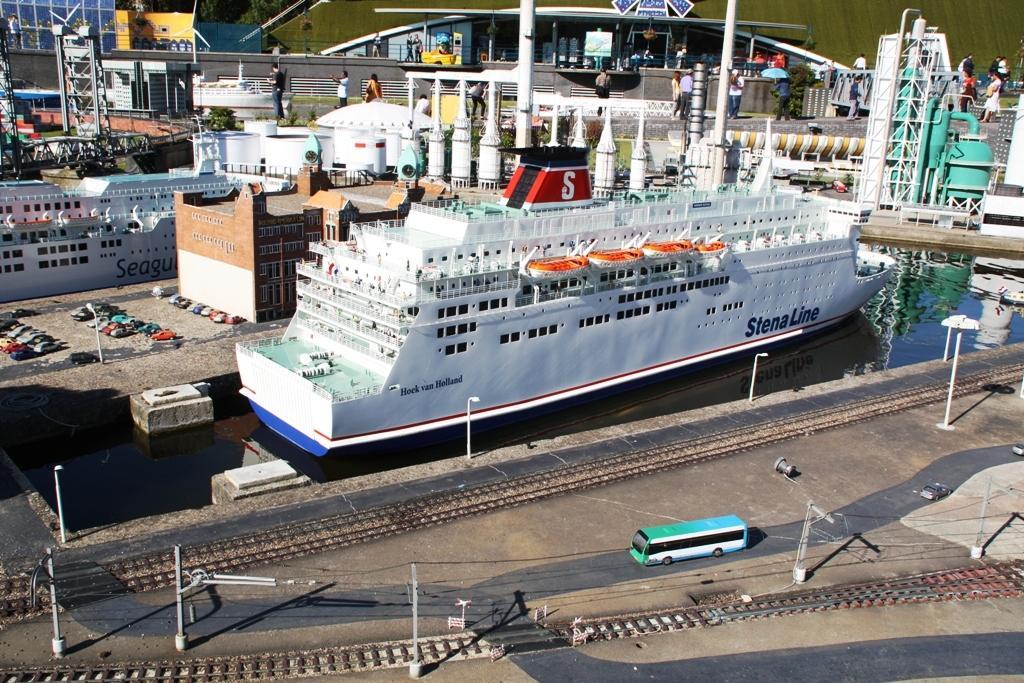Could you give a brief overview of what you see in this image? Here in this picture, in the front we can see railway tracks present on the road and we can also see a bus present and we can see light posts present and we can see water present over a place and in that we can see a ship present and we can also see other buildings present and in the far we can see number of people standing and walking on the road and we can see towers present and we can also see some cars present near the building on the left side. 